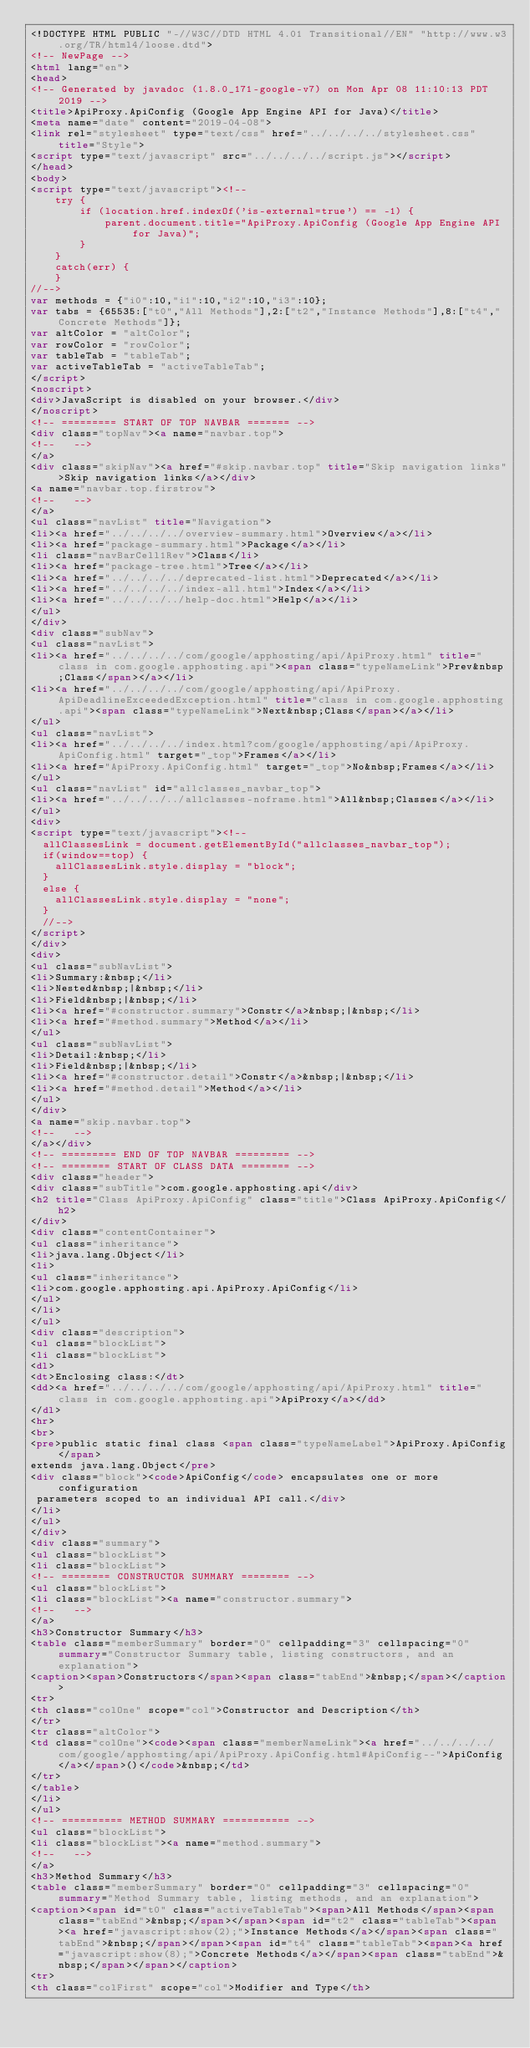Convert code to text. <code><loc_0><loc_0><loc_500><loc_500><_HTML_><!DOCTYPE HTML PUBLIC "-//W3C//DTD HTML 4.01 Transitional//EN" "http://www.w3.org/TR/html4/loose.dtd">
<!-- NewPage -->
<html lang="en">
<head>
<!-- Generated by javadoc (1.8.0_171-google-v7) on Mon Apr 08 11:10:13 PDT 2019 -->
<title>ApiProxy.ApiConfig (Google App Engine API for Java)</title>
<meta name="date" content="2019-04-08">
<link rel="stylesheet" type="text/css" href="../../../../stylesheet.css" title="Style">
<script type="text/javascript" src="../../../../script.js"></script>
</head>
<body>
<script type="text/javascript"><!--
    try {
        if (location.href.indexOf('is-external=true') == -1) {
            parent.document.title="ApiProxy.ApiConfig (Google App Engine API for Java)";
        }
    }
    catch(err) {
    }
//-->
var methods = {"i0":10,"i1":10,"i2":10,"i3":10};
var tabs = {65535:["t0","All Methods"],2:["t2","Instance Methods"],8:["t4","Concrete Methods"]};
var altColor = "altColor";
var rowColor = "rowColor";
var tableTab = "tableTab";
var activeTableTab = "activeTableTab";
</script>
<noscript>
<div>JavaScript is disabled on your browser.</div>
</noscript>
<!-- ========= START OF TOP NAVBAR ======= -->
<div class="topNav"><a name="navbar.top">
<!--   -->
</a>
<div class="skipNav"><a href="#skip.navbar.top" title="Skip navigation links">Skip navigation links</a></div>
<a name="navbar.top.firstrow">
<!--   -->
</a>
<ul class="navList" title="Navigation">
<li><a href="../../../../overview-summary.html">Overview</a></li>
<li><a href="package-summary.html">Package</a></li>
<li class="navBarCell1Rev">Class</li>
<li><a href="package-tree.html">Tree</a></li>
<li><a href="../../../../deprecated-list.html">Deprecated</a></li>
<li><a href="../../../../index-all.html">Index</a></li>
<li><a href="../../../../help-doc.html">Help</a></li>
</ul>
</div>
<div class="subNav">
<ul class="navList">
<li><a href="../../../../com/google/apphosting/api/ApiProxy.html" title="class in com.google.apphosting.api"><span class="typeNameLink">Prev&nbsp;Class</span></a></li>
<li><a href="../../../../com/google/apphosting/api/ApiProxy.ApiDeadlineExceededException.html" title="class in com.google.apphosting.api"><span class="typeNameLink">Next&nbsp;Class</span></a></li>
</ul>
<ul class="navList">
<li><a href="../../../../index.html?com/google/apphosting/api/ApiProxy.ApiConfig.html" target="_top">Frames</a></li>
<li><a href="ApiProxy.ApiConfig.html" target="_top">No&nbsp;Frames</a></li>
</ul>
<ul class="navList" id="allclasses_navbar_top">
<li><a href="../../../../allclasses-noframe.html">All&nbsp;Classes</a></li>
</ul>
<div>
<script type="text/javascript"><!--
  allClassesLink = document.getElementById("allclasses_navbar_top");
  if(window==top) {
    allClassesLink.style.display = "block";
  }
  else {
    allClassesLink.style.display = "none";
  }
  //-->
</script>
</div>
<div>
<ul class="subNavList">
<li>Summary:&nbsp;</li>
<li>Nested&nbsp;|&nbsp;</li>
<li>Field&nbsp;|&nbsp;</li>
<li><a href="#constructor.summary">Constr</a>&nbsp;|&nbsp;</li>
<li><a href="#method.summary">Method</a></li>
</ul>
<ul class="subNavList">
<li>Detail:&nbsp;</li>
<li>Field&nbsp;|&nbsp;</li>
<li><a href="#constructor.detail">Constr</a>&nbsp;|&nbsp;</li>
<li><a href="#method.detail">Method</a></li>
</ul>
</div>
<a name="skip.navbar.top">
<!--   -->
</a></div>
<!-- ========= END OF TOP NAVBAR ========= -->
<!-- ======== START OF CLASS DATA ======== -->
<div class="header">
<div class="subTitle">com.google.apphosting.api</div>
<h2 title="Class ApiProxy.ApiConfig" class="title">Class ApiProxy.ApiConfig</h2>
</div>
<div class="contentContainer">
<ul class="inheritance">
<li>java.lang.Object</li>
<li>
<ul class="inheritance">
<li>com.google.apphosting.api.ApiProxy.ApiConfig</li>
</ul>
</li>
</ul>
<div class="description">
<ul class="blockList">
<li class="blockList">
<dl>
<dt>Enclosing class:</dt>
<dd><a href="../../../../com/google/apphosting/api/ApiProxy.html" title="class in com.google.apphosting.api">ApiProxy</a></dd>
</dl>
<hr>
<br>
<pre>public static final class <span class="typeNameLabel">ApiProxy.ApiConfig</span>
extends java.lang.Object</pre>
<div class="block"><code>ApiConfig</code> encapsulates one or more configuration
 parameters scoped to an individual API call.</div>
</li>
</ul>
</div>
<div class="summary">
<ul class="blockList">
<li class="blockList">
<!-- ======== CONSTRUCTOR SUMMARY ======== -->
<ul class="blockList">
<li class="blockList"><a name="constructor.summary">
<!--   -->
</a>
<h3>Constructor Summary</h3>
<table class="memberSummary" border="0" cellpadding="3" cellspacing="0" summary="Constructor Summary table, listing constructors, and an explanation">
<caption><span>Constructors</span><span class="tabEnd">&nbsp;</span></caption>
<tr>
<th class="colOne" scope="col">Constructor and Description</th>
</tr>
<tr class="altColor">
<td class="colOne"><code><span class="memberNameLink"><a href="../../../../com/google/apphosting/api/ApiProxy.ApiConfig.html#ApiConfig--">ApiConfig</a></span>()</code>&nbsp;</td>
</tr>
</table>
</li>
</ul>
<!-- ========== METHOD SUMMARY =========== -->
<ul class="blockList">
<li class="blockList"><a name="method.summary">
<!--   -->
</a>
<h3>Method Summary</h3>
<table class="memberSummary" border="0" cellpadding="3" cellspacing="0" summary="Method Summary table, listing methods, and an explanation">
<caption><span id="t0" class="activeTableTab"><span>All Methods</span><span class="tabEnd">&nbsp;</span></span><span id="t2" class="tableTab"><span><a href="javascript:show(2);">Instance Methods</a></span><span class="tabEnd">&nbsp;</span></span><span id="t4" class="tableTab"><span><a href="javascript:show(8);">Concrete Methods</a></span><span class="tabEnd">&nbsp;</span></span></caption>
<tr>
<th class="colFirst" scope="col">Modifier and Type</th></code> 